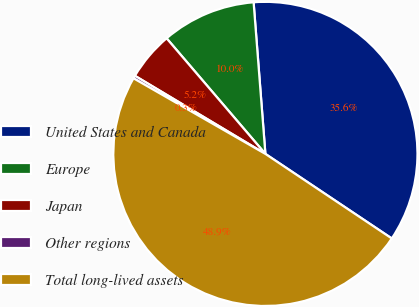Convert chart. <chart><loc_0><loc_0><loc_500><loc_500><pie_chart><fcel>United States and Canada<fcel>Europe<fcel>Japan<fcel>Other regions<fcel>Total long-lived assets<nl><fcel>35.62%<fcel>10.02%<fcel>5.16%<fcel>0.3%<fcel>48.9%<nl></chart> 